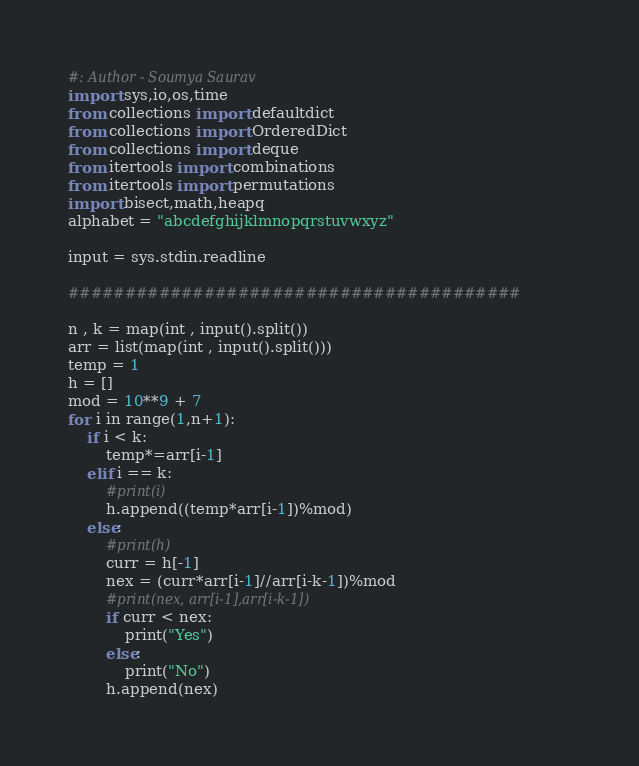<code> <loc_0><loc_0><loc_500><loc_500><_Python_>#: Author - Soumya Saurav
import sys,io,os,time
from collections import defaultdict
from collections import OrderedDict
from collections import deque
from itertools import combinations
from itertools import permutations
import bisect,math,heapq
alphabet = "abcdefghijklmnopqrstuvwxyz"

input = sys.stdin.readline

########################################

n , k = map(int , input().split())
arr = list(map(int , input().split()))
temp = 1
h = []
mod = 10**9 + 7
for i in range(1,n+1):
	if i < k:
		temp*=arr[i-1]
	elif i == k:
		#print(i)
		h.append((temp*arr[i-1])%mod)
	else:
		#print(h)
		curr = h[-1]
		nex = (curr*arr[i-1]//arr[i-k-1])%mod
		#print(nex, arr[i-1],arr[i-k-1])
		if curr < nex:
			print("Yes")
		else:
			print("No")
		h.append(nex)








</code> 